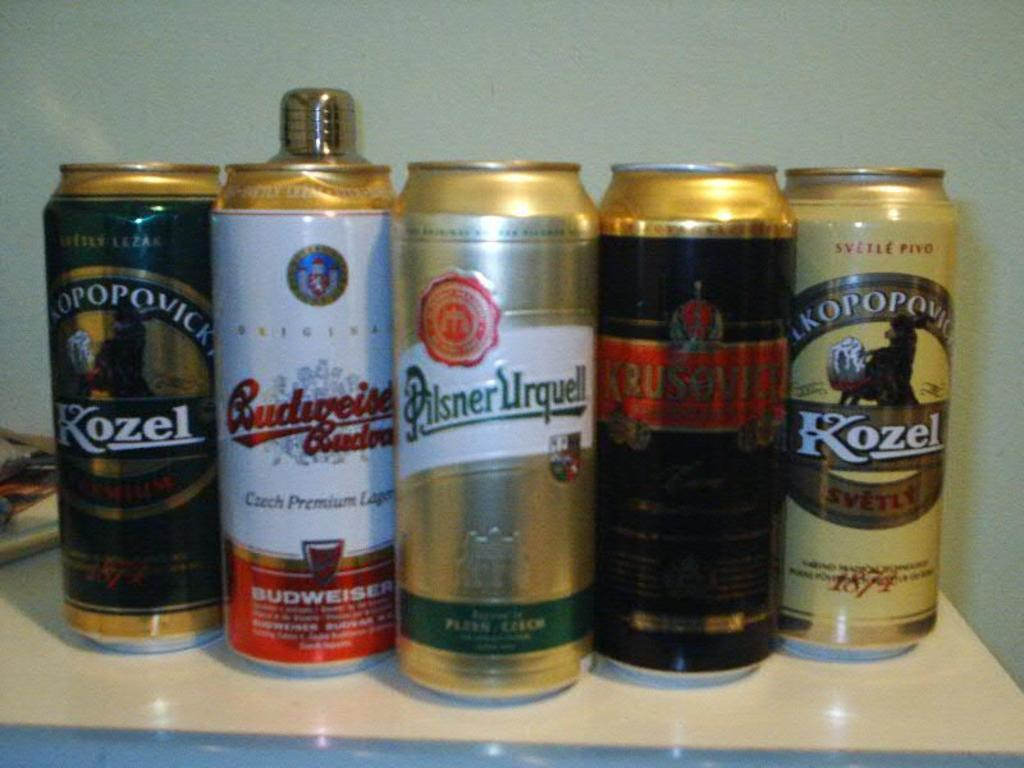<image>
Provide a brief description of the given image. Five cans of beer with Pilsner Urquell in the middle. 